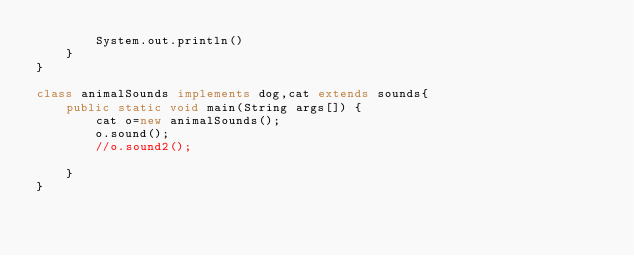Convert code to text. <code><loc_0><loc_0><loc_500><loc_500><_Java_>        System.out.println()
    }
}

class animalSounds implements dog,cat extends sounds{
    public static void main(String args[]) {
        cat o=new animalSounds();
        o.sound();
        //o.sound2();
        
    }
}</code> 